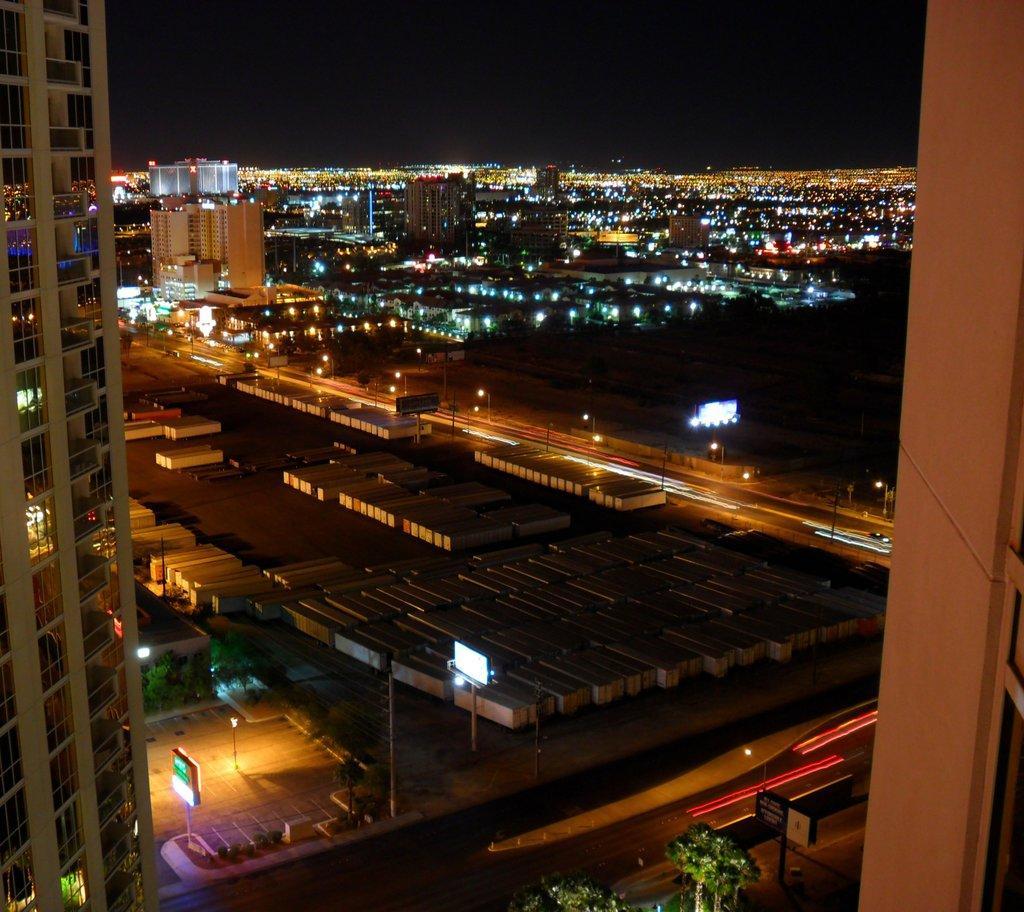Describe this image in one or two sentences. In this image, we can see some buildings and we can see some lights. 